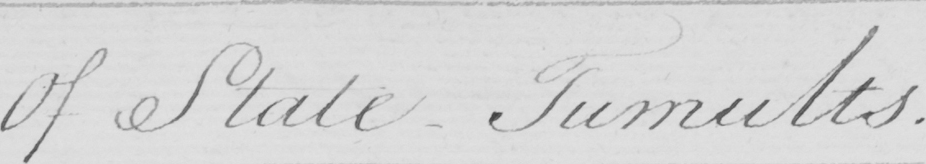Can you read and transcribe this handwriting? Of State-Tumults . 